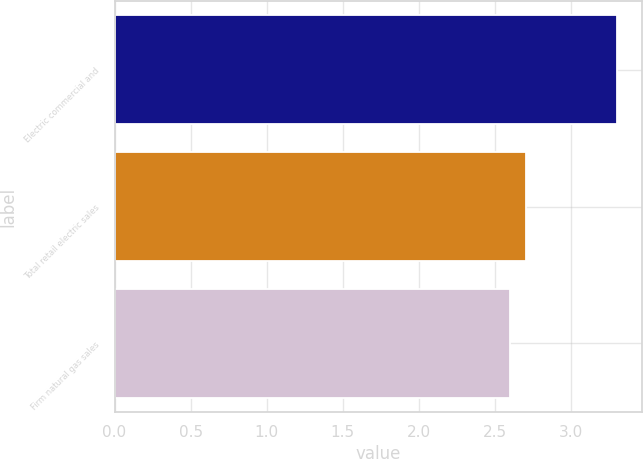Convert chart to OTSL. <chart><loc_0><loc_0><loc_500><loc_500><bar_chart><fcel>Electric commercial and<fcel>Total retail electric sales<fcel>Firm natural gas sales<nl><fcel>3.3<fcel>2.7<fcel>2.6<nl></chart> 